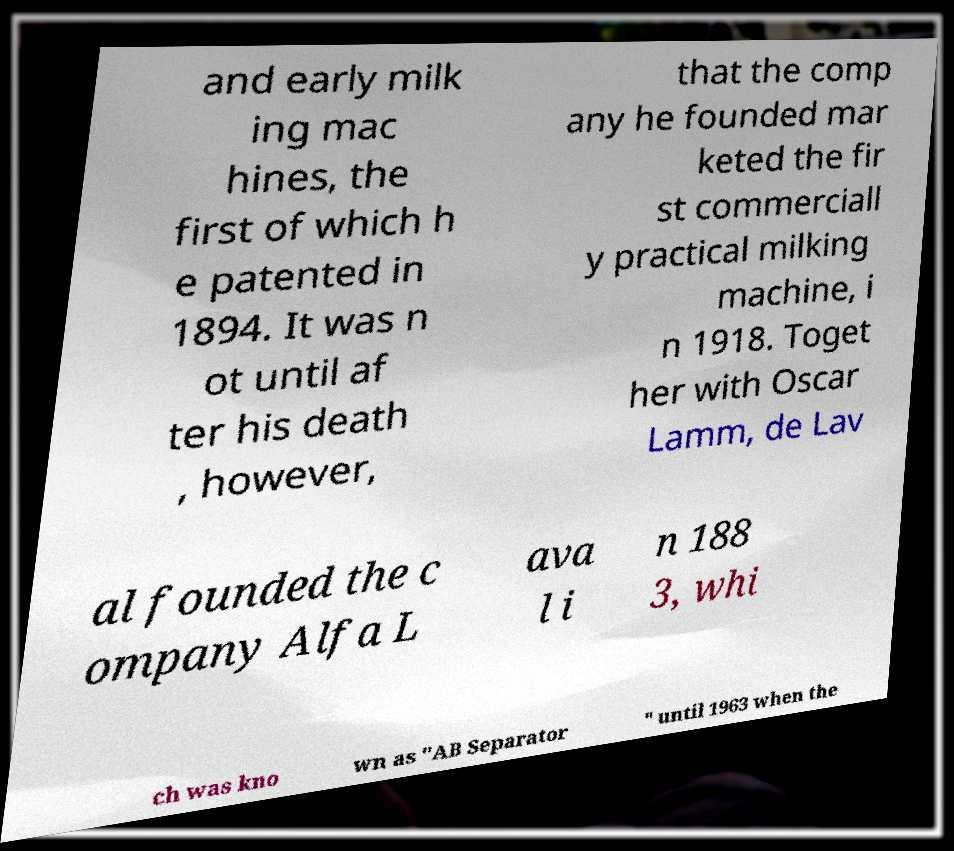For documentation purposes, I need the text within this image transcribed. Could you provide that? and early milk ing mac hines, the first of which h e patented in 1894. It was n ot until af ter his death , however, that the comp any he founded mar keted the fir st commerciall y practical milking machine, i n 1918. Toget her with Oscar Lamm, de Lav al founded the c ompany Alfa L ava l i n 188 3, whi ch was kno wn as "AB Separator " until 1963 when the 